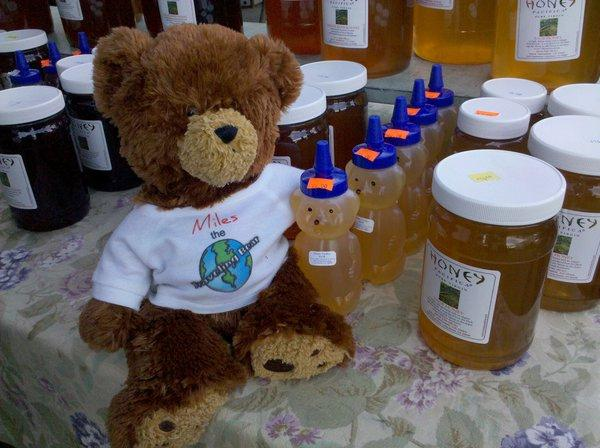What color are the tags on top of the honey dispensers? Please explain your reasoning. orange. The honey dispensers have blue lids and have orange tags stuck to them. 